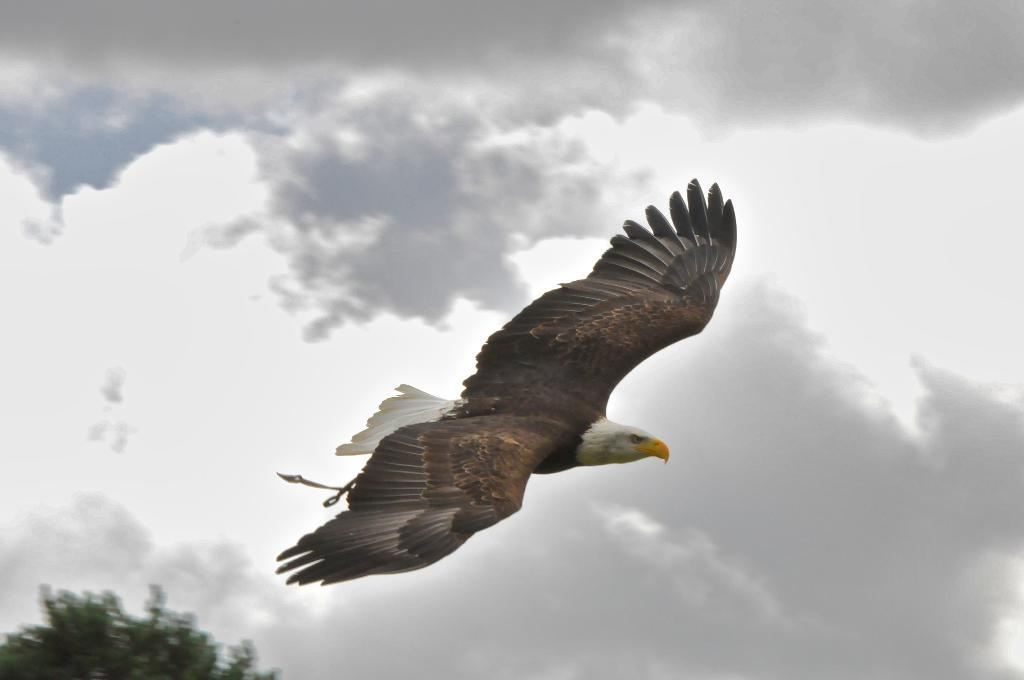What animal is featured in the image? There is an eagle in the image. What is the eagle doing in the image? The eagle is flying. What can be seen in the bottom left corner of the image? There is a tree in the bottom left corner of the image. What is visible in the background of the image? The sky is visible in the image. How would you describe the weather based on the image? The sky appears to be cloudy, which might suggest overcast or cloudy weather. How many cars are parked near the tree in the image? There are no cars present in the image; it features an eagle flying and a tree in the bottom left corner. What type of basin is visible in the image? There is no basin present in the image. 